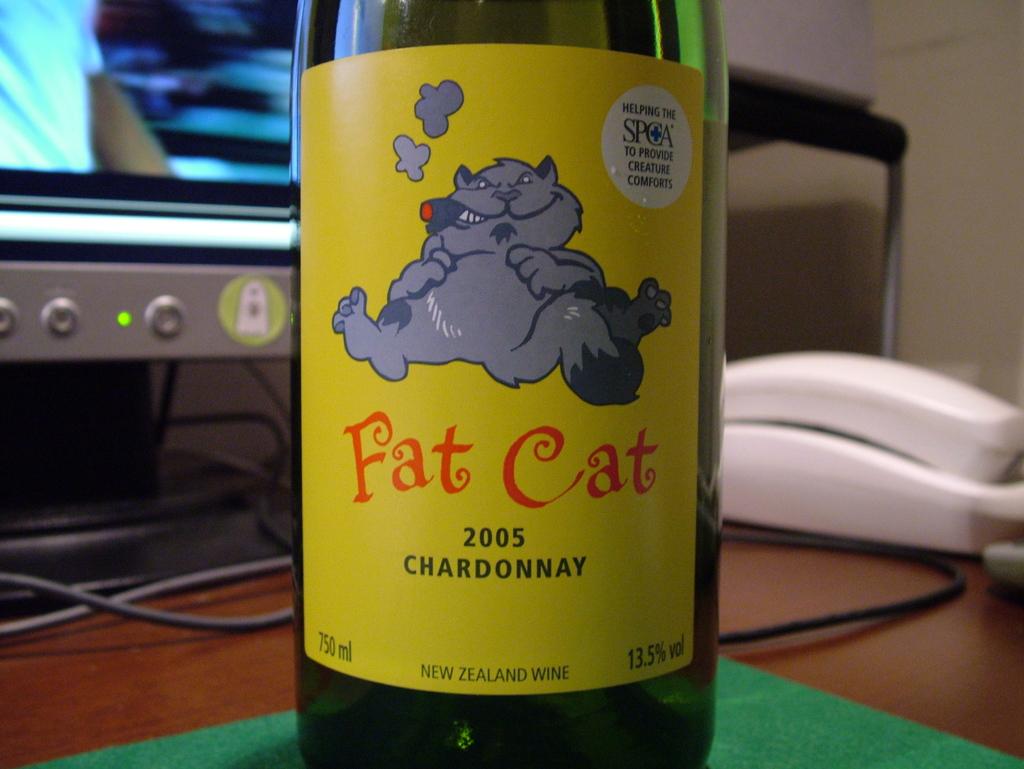What year is this bottle?
Provide a short and direct response. 2005. 